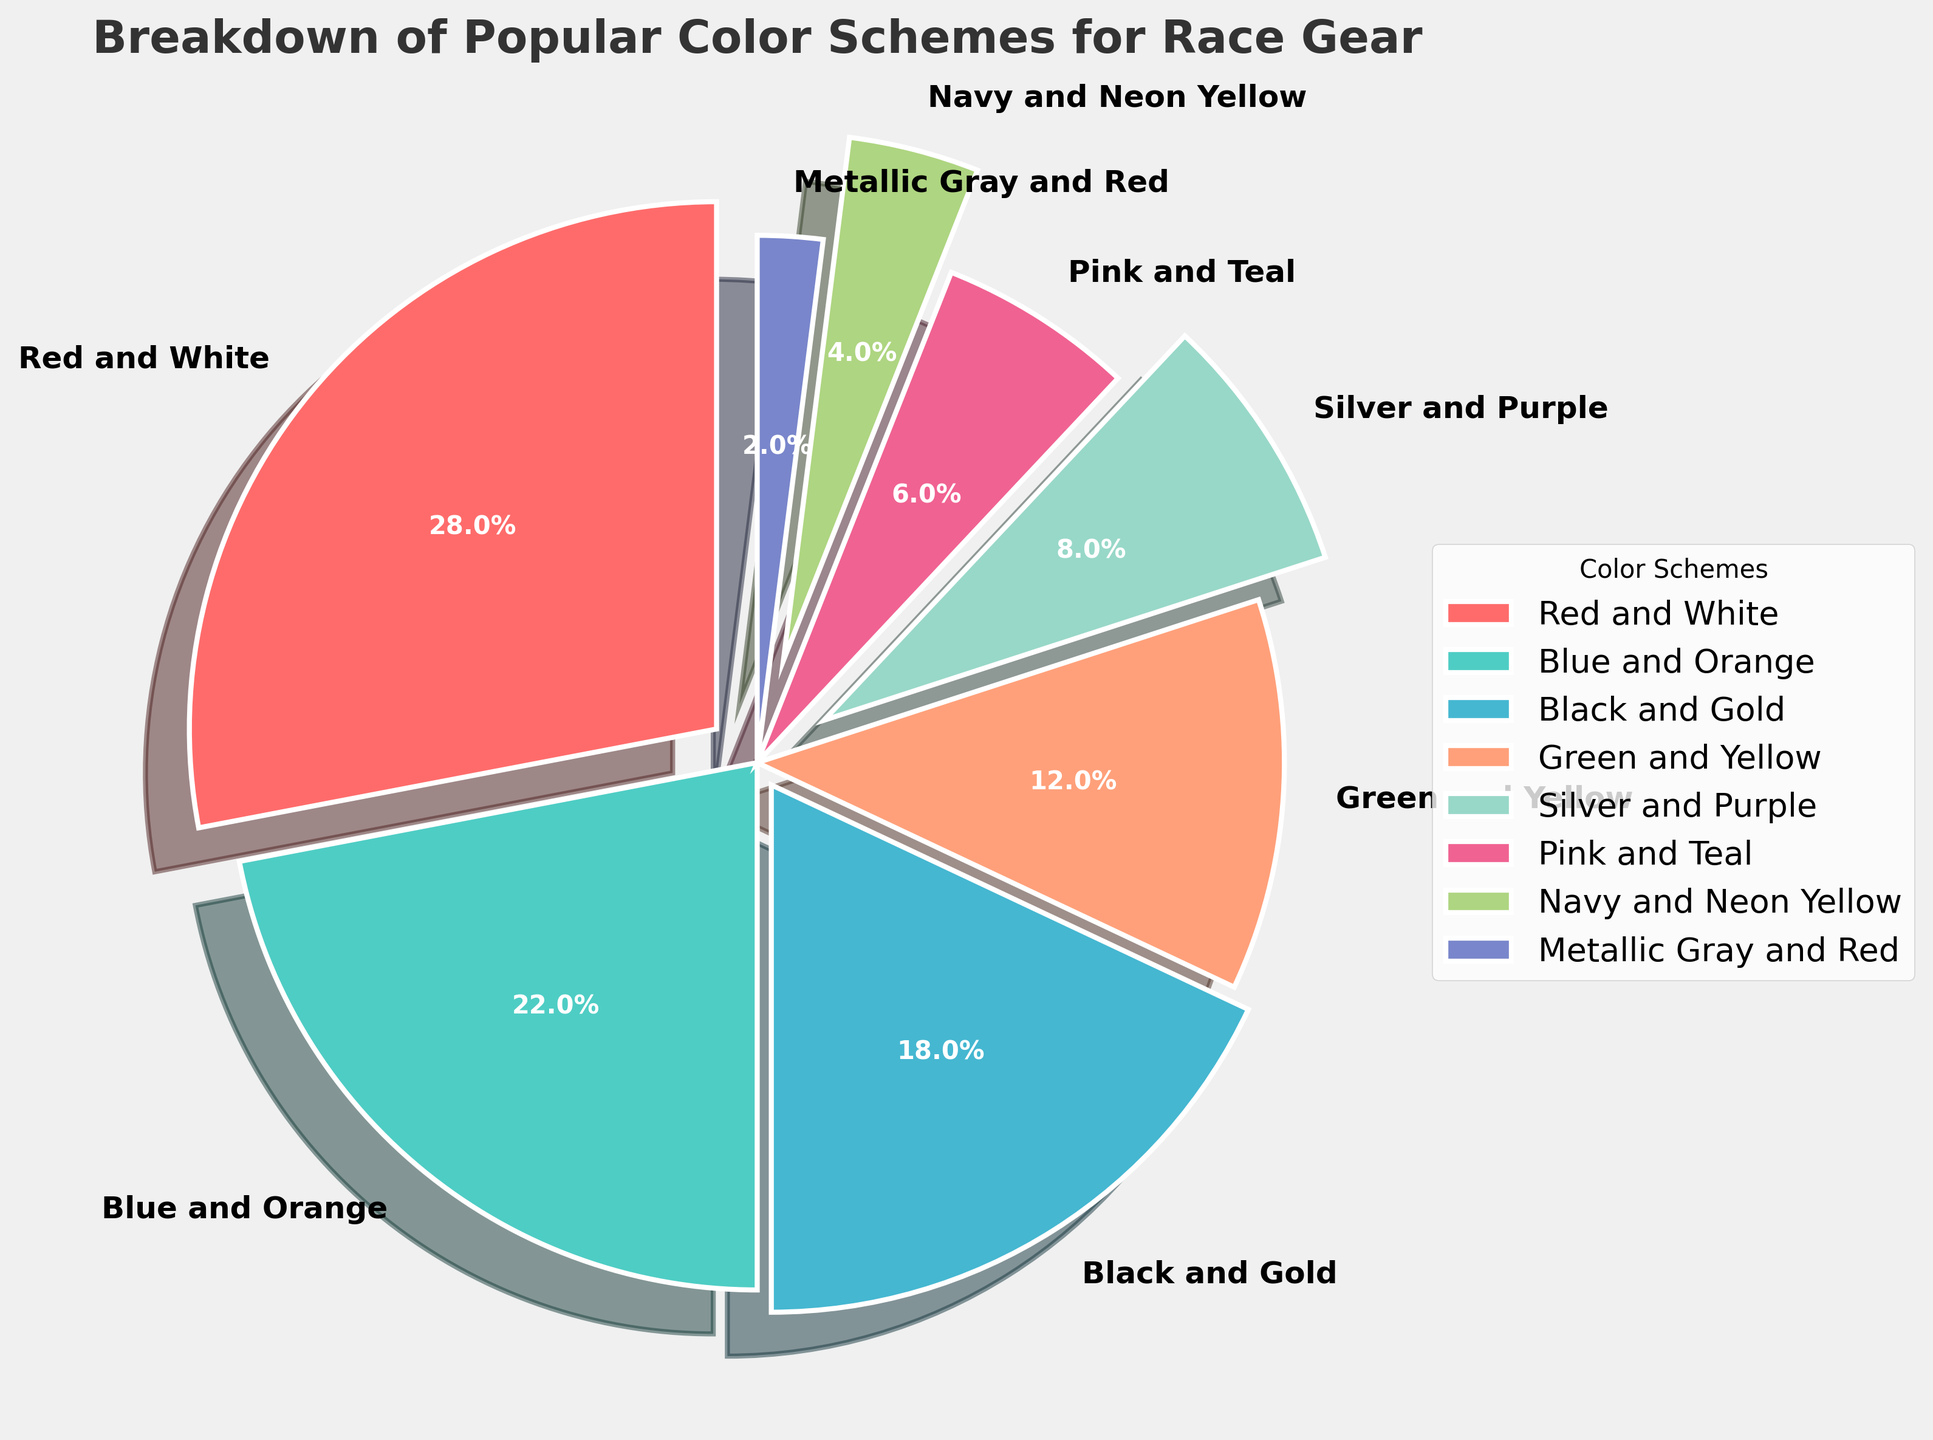Which color scheme is the most popular? The most popular color scheme is the one with the largest percentage in the pie chart. From the chart, Red and White takes up the largest portion of the pie at 28%.
Answer: Red and White What is the percentage difference between Blue and Orange and Black and Gold? To find the percentage difference, subtract the percentage of Black and Gold from that of Blue and Orange: 22% - 18% = 4%.
Answer: 4% How many color schemes have percentages greater than 10%? By examining the pie chart, the color schemes with percentages greater than 10% are Red and White (28%), Blue and Orange (22%), Black and Gold (18%), and Green and Yellow (12%). So, there are 4 of them.
Answer: 4 Which color scheme has the smallest percentage? The color scheme with the smallest percentage is the one with the smallest portion in the pie chart. Metallic Gray and Red has the smallest percentage at 2%.
Answer: Metallic Gray and Red What is the cumulative percentage of the top three color schemes? To find the cumulative percentage, add the percentages of the top three color schemes: Red and White (28%) + Blue and Orange (22%) + Black and Gold (18%) = 68%.
Answer: 68% Are there more color schemes with percentages under 10% or over 10%? Count the color schemes under and over 10%: under 10% (Silver and Purple, Pink and Teal, Navy and Neon Yellow, Metallic Gray and Red) = 4; over 10% (Red and White, Blue and Orange, Black and Gold, Green and Yellow) = 4. Both categories have an equal number of color schemes.
Answer: Equal What percentage of the pie chart is constituted by color schemes containing "Red"? Identify and sum the percentages for color schemes containing "Red": Red and White (28%) + Metallic Gray and Red (2%) = 30%.
Answer: 30% Which two color schemes combined make up the largest percentage? To determine this, find the sum of the two largest percentages: Red and White (28%) + Blue and Orange (22%) = 50%.
Answer: Red and White and Blue and Orange How does the percentage of Green and Yellow compare to that of Silver and Purple? Green and Yellow has a percentage of 12% and Silver and Purple has 8%. Thus, Green and Yellow has a higher percentage than Silver and Purple by 4%.
Answer: Green and Yellow is higher by 4% 